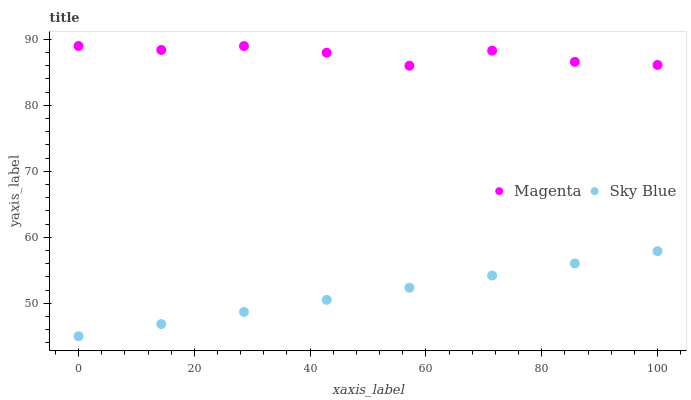Does Sky Blue have the minimum area under the curve?
Answer yes or no. Yes. Does Magenta have the maximum area under the curve?
Answer yes or no. Yes. Does Magenta have the minimum area under the curve?
Answer yes or no. No. Is Sky Blue the smoothest?
Answer yes or no. Yes. Is Magenta the roughest?
Answer yes or no. Yes. Is Magenta the smoothest?
Answer yes or no. No. Does Sky Blue have the lowest value?
Answer yes or no. Yes. Does Magenta have the lowest value?
Answer yes or no. No. Does Magenta have the highest value?
Answer yes or no. Yes. Is Sky Blue less than Magenta?
Answer yes or no. Yes. Is Magenta greater than Sky Blue?
Answer yes or no. Yes. Does Sky Blue intersect Magenta?
Answer yes or no. No. 